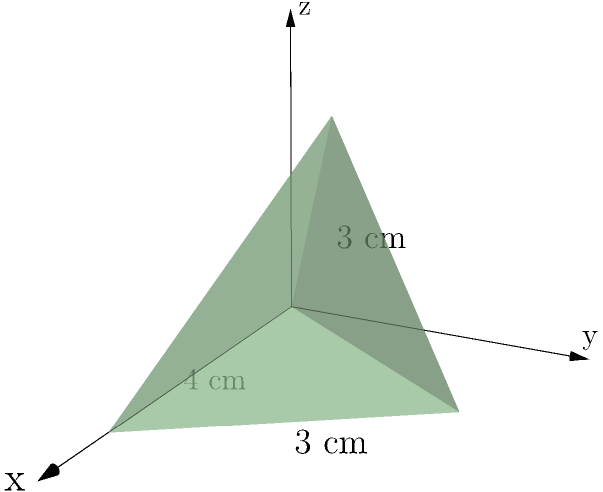In a shocking twist on "Passions of Paradise," Esmeralda wins the coveted "Best Scheming Villain" award at the Soap Opera Digest Awards. The trophy is a pyramid-shaped crystal with a square base of side length 4 cm and a height of 3 cm. What is the surface area of Esmeralda's trophy in square centimeters? Let's approach this step-by-step:

1) The trophy is a square pyramid. We need to calculate the area of the base and the areas of the four triangular faces.

2) Area of the base:
   $A_{base} = 4 \text{ cm} \times 4 \text{ cm} = 16 \text{ cm}^2$

3) For the triangular faces, we need to find their height (slant height of the pyramid):
   Let's call the slant height $s$.
   Using the Pythagorean theorem: $s^2 = (\frac{4}{2})^2 + 3^2 = 2^2 + 3^2 = 4 + 9 = 13$
   $s = \sqrt{13} \text{ cm}$

4) Area of each triangular face:
   $A_{face} = \frac{1}{2} \times 4 \text{ cm} \times \sqrt{13} \text{ cm} = 2\sqrt{13} \text{ cm}^2$

5) Total surface area:
   $SA = A_{base} + 4 \times A_{face}$
   $SA = 16 \text{ cm}^2 + 4 \times 2\sqrt{13} \text{ cm}^2$
   $SA = 16 + 8\sqrt{13} \text{ cm}^2$

Therefore, the surface area of Esmeralda's trophy is $16 + 8\sqrt{13}$ square centimeters.
Answer: $16 + 8\sqrt{13} \text{ cm}^2$ 